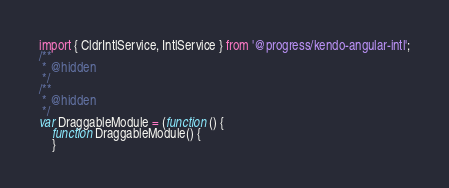<code> <loc_0><loc_0><loc_500><loc_500><_JavaScript_>import { CldrIntlService, IntlService } from '@progress/kendo-angular-intl';
/**
 * @hidden
 */
/**
 * @hidden
 */
var DraggableModule = (function () {
    function DraggableModule() {
    }</code> 